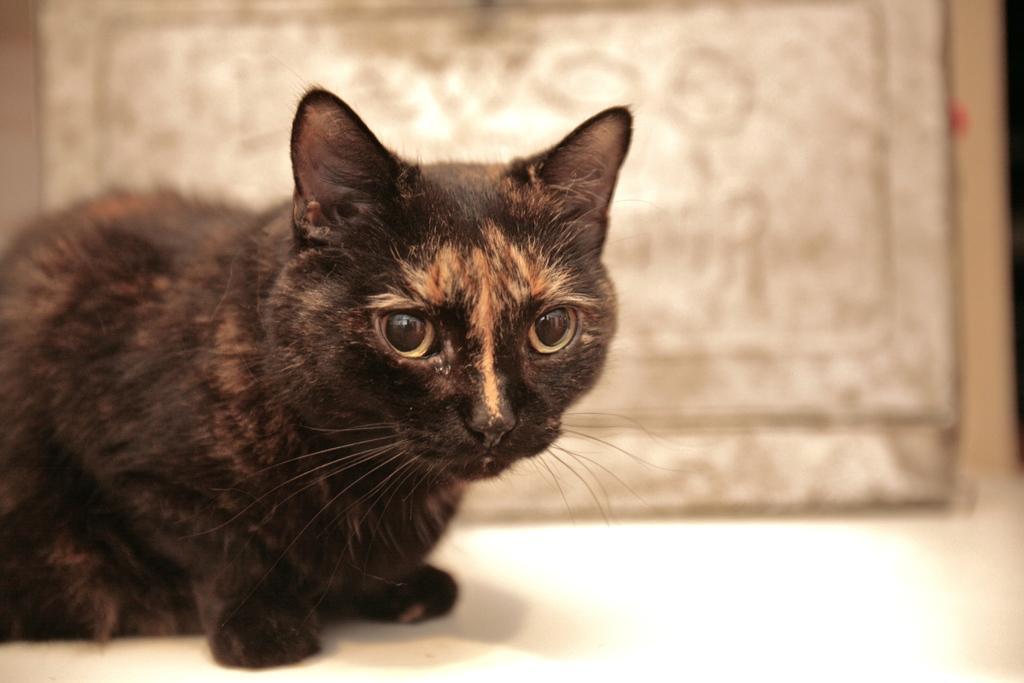Could you give a brief overview of what you see in this image? On the left side of the image, we can see a cat on the white surface. Background we can see the blur view. 